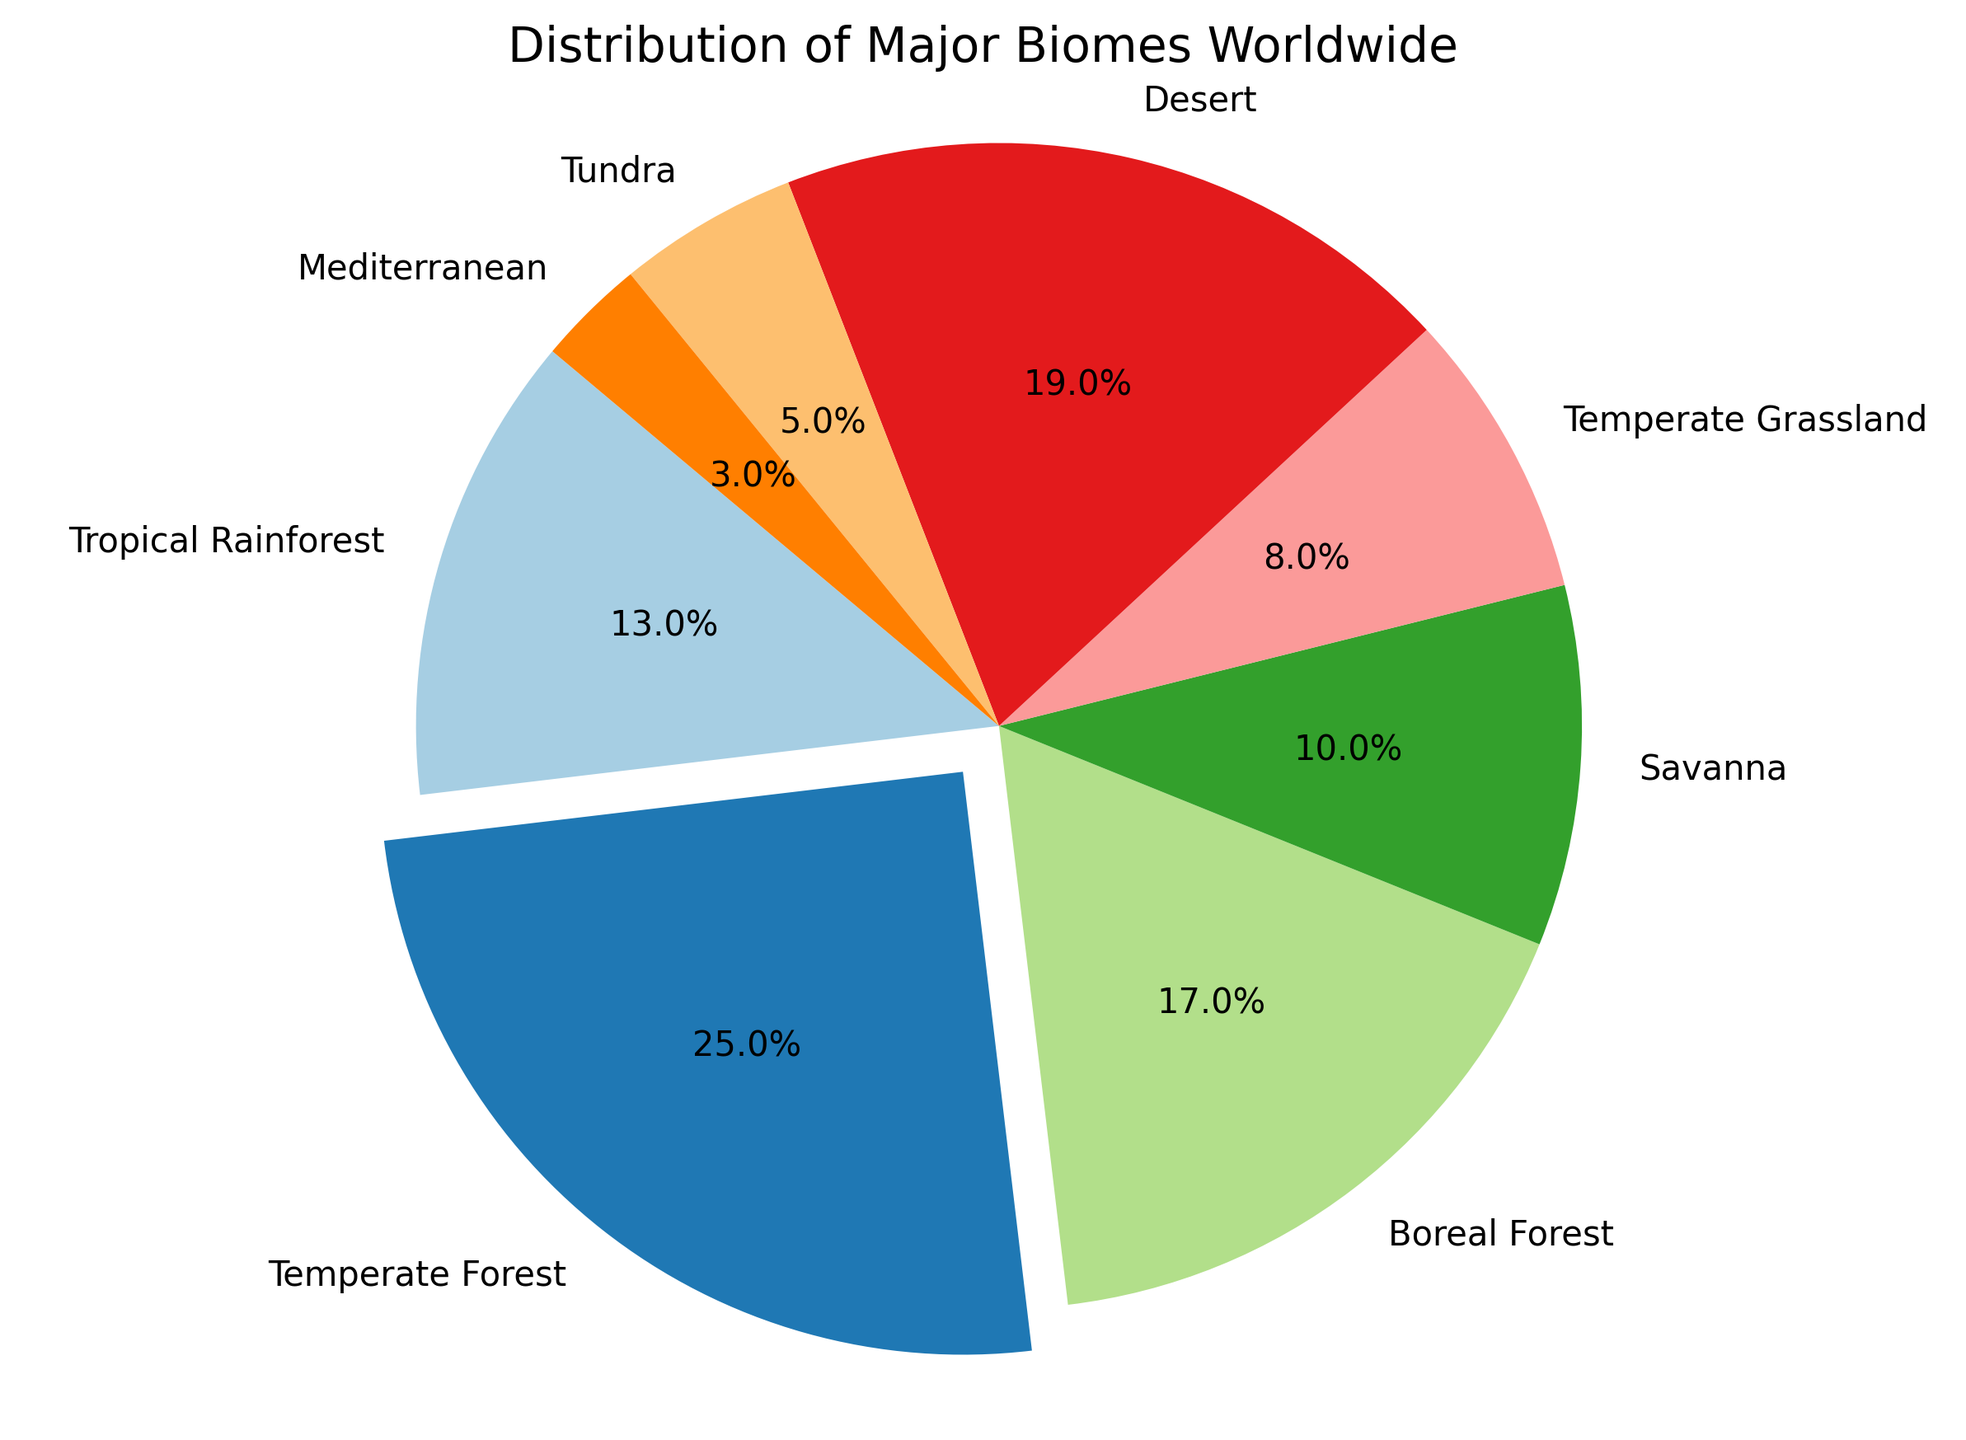Which biome has the largest percentage in the distribution? The largest percentage can be identified by the exploded slice in the pie chart, which is marked to stand out.
Answer: Temperate Forest What percentage of the world's biomes are Temperate Forest and Boreal Forest combined? Add the percentage values for Temperate Forest (25%) and Boreal Forest (17%). 25 + 17 = 42
Answer: 42% Which biomes have a smaller percentage compared to the Desert biome? Compare each biome's percentage with the Desert biome's percentage (19%). Biomes with smaller percentages are Savanna (10%), Temperate Grassland (8%), Tundra (5%), and Mediterranean (3%).
Answer: Savanna, Temperate Grassland, Tundra, Mediterranean How much larger is the Temperate Forest's percentage compared to the Tropical Rainforest's percentage? Subtract Tropical Rainforest's percentage (13%) from Temperate Forest's percentage (25%). 25 - 13 = 12
Answer: 12% What is the combined percentage of the Savanna, Temperate Grassland, Tundra, and Mediterranean biomes? Sum the percentages of Savanna (10%), Temperate Grassland (8%), Tundra (5%), and Mediterranean (3%). 10 + 8 + 5 + 3 = 26
Answer: 26% Which color represents the Tundra biome in the pie chart? Identify the color associated with the label "Tundra" in the pie chart.
Answer: Varies (depend on the specific rendering in the chart, e.g., light blue or another specific color) Is the percentage of the Desert biome greater than or equal to that of Temperate Grassland and Mediterranean combined? Add the percentages of Temperate Grassland (8%) and Mediterranean (3%), then compare with Desert (19%). 8 + 3 = 11, and 19 > 11.
Answer: Yes Which biomes combined make up less than 10% of the distribution? Identify biomes whose individual percentage values sum up to less than 10%. Only the Mediterranean biome (3%) fits this criteria.
Answer: Mediterranean Which two biomes together constitute a quarter of the world's biomes distribution? Find two biomes whose combined percentages sum up to 25%. Boreal Forest (17%) and Savanna (10%) sum to 27%, which is close but not exact. The correct pair is Savanna (10%) and Temperate Grassland (8%) only equals 18%, not 25%.
Answer: No pair fits exactly 